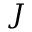<formula> <loc_0><loc_0><loc_500><loc_500>J</formula> 